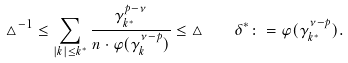<formula> <loc_0><loc_0><loc_500><loc_500>\triangle ^ { - 1 } \leq \sum _ { | k | \leq k ^ { * } } \frac { \gamma _ { k ^ { * } } ^ { p - \nu } } { n \cdot \varphi ( \gamma _ { k } ^ { \nu - p } ) } \leq \triangle \quad \delta ^ { * } \colon = \varphi ( \gamma _ { k ^ { * } } ^ { \nu - p } ) .</formula> 